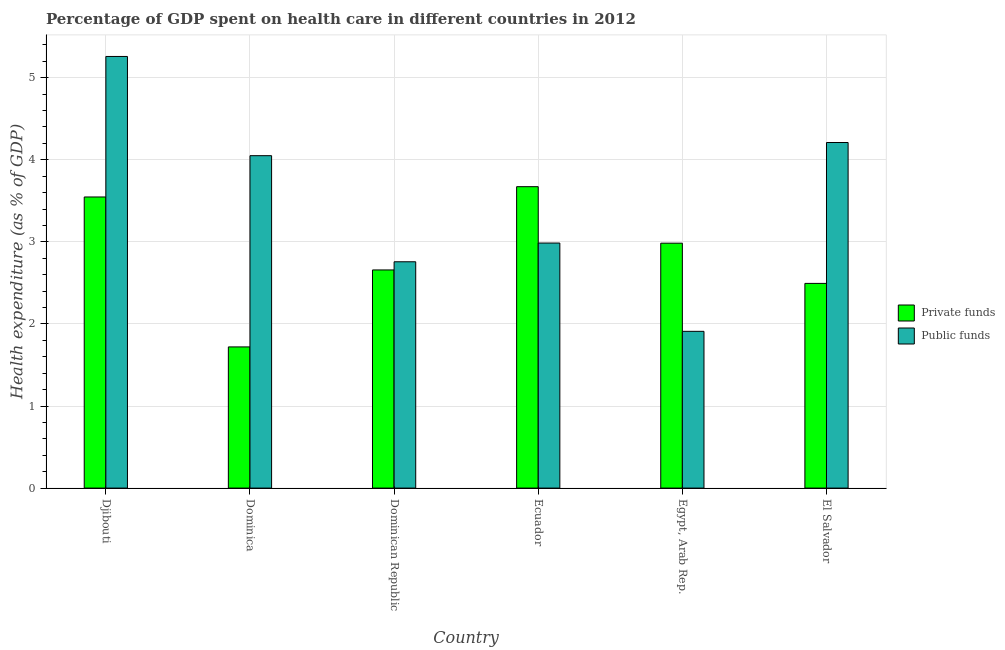How many different coloured bars are there?
Keep it short and to the point. 2. Are the number of bars on each tick of the X-axis equal?
Your response must be concise. Yes. What is the label of the 5th group of bars from the left?
Provide a short and direct response. Egypt, Arab Rep. What is the amount of public funds spent in healthcare in El Salvador?
Provide a succinct answer. 4.21. Across all countries, what is the maximum amount of public funds spent in healthcare?
Your answer should be compact. 5.26. Across all countries, what is the minimum amount of public funds spent in healthcare?
Give a very brief answer. 1.91. In which country was the amount of private funds spent in healthcare maximum?
Offer a very short reply. Ecuador. In which country was the amount of public funds spent in healthcare minimum?
Your answer should be compact. Egypt, Arab Rep. What is the total amount of private funds spent in healthcare in the graph?
Ensure brevity in your answer.  17.07. What is the difference between the amount of public funds spent in healthcare in Djibouti and that in Dominican Republic?
Your answer should be very brief. 2.5. What is the difference between the amount of public funds spent in healthcare in Ecuador and the amount of private funds spent in healthcare in El Salvador?
Give a very brief answer. 0.49. What is the average amount of public funds spent in healthcare per country?
Provide a succinct answer. 3.53. What is the difference between the amount of private funds spent in healthcare and amount of public funds spent in healthcare in Dominica?
Make the answer very short. -2.33. What is the ratio of the amount of private funds spent in healthcare in Djibouti to that in Dominica?
Provide a short and direct response. 2.06. Is the amount of public funds spent in healthcare in Djibouti less than that in El Salvador?
Provide a short and direct response. No. Is the difference between the amount of private funds spent in healthcare in Djibouti and Dominican Republic greater than the difference between the amount of public funds spent in healthcare in Djibouti and Dominican Republic?
Give a very brief answer. No. What is the difference between the highest and the second highest amount of public funds spent in healthcare?
Ensure brevity in your answer.  1.05. What is the difference between the highest and the lowest amount of private funds spent in healthcare?
Your answer should be compact. 1.95. Is the sum of the amount of private funds spent in healthcare in Djibouti and Ecuador greater than the maximum amount of public funds spent in healthcare across all countries?
Ensure brevity in your answer.  Yes. What does the 1st bar from the left in Dominica represents?
Your answer should be compact. Private funds. What does the 2nd bar from the right in Dominica represents?
Offer a terse response. Private funds. How many bars are there?
Your answer should be very brief. 12. Are the values on the major ticks of Y-axis written in scientific E-notation?
Give a very brief answer. No. How many legend labels are there?
Give a very brief answer. 2. What is the title of the graph?
Provide a succinct answer. Percentage of GDP spent on health care in different countries in 2012. What is the label or title of the X-axis?
Offer a terse response. Country. What is the label or title of the Y-axis?
Provide a short and direct response. Health expenditure (as % of GDP). What is the Health expenditure (as % of GDP) in Private funds in Djibouti?
Offer a terse response. 3.55. What is the Health expenditure (as % of GDP) of Public funds in Djibouti?
Keep it short and to the point. 5.26. What is the Health expenditure (as % of GDP) in Private funds in Dominica?
Ensure brevity in your answer.  1.72. What is the Health expenditure (as % of GDP) in Public funds in Dominica?
Keep it short and to the point. 4.05. What is the Health expenditure (as % of GDP) of Private funds in Dominican Republic?
Provide a succinct answer. 2.66. What is the Health expenditure (as % of GDP) in Public funds in Dominican Republic?
Offer a terse response. 2.76. What is the Health expenditure (as % of GDP) in Private funds in Ecuador?
Your answer should be compact. 3.67. What is the Health expenditure (as % of GDP) of Public funds in Ecuador?
Give a very brief answer. 2.99. What is the Health expenditure (as % of GDP) in Private funds in Egypt, Arab Rep.?
Provide a short and direct response. 2.98. What is the Health expenditure (as % of GDP) of Public funds in Egypt, Arab Rep.?
Provide a succinct answer. 1.91. What is the Health expenditure (as % of GDP) in Private funds in El Salvador?
Keep it short and to the point. 2.49. What is the Health expenditure (as % of GDP) of Public funds in El Salvador?
Give a very brief answer. 4.21. Across all countries, what is the maximum Health expenditure (as % of GDP) in Private funds?
Keep it short and to the point. 3.67. Across all countries, what is the maximum Health expenditure (as % of GDP) of Public funds?
Your response must be concise. 5.26. Across all countries, what is the minimum Health expenditure (as % of GDP) in Private funds?
Keep it short and to the point. 1.72. Across all countries, what is the minimum Health expenditure (as % of GDP) of Public funds?
Offer a very short reply. 1.91. What is the total Health expenditure (as % of GDP) of Private funds in the graph?
Your answer should be compact. 17.07. What is the total Health expenditure (as % of GDP) of Public funds in the graph?
Keep it short and to the point. 21.17. What is the difference between the Health expenditure (as % of GDP) of Private funds in Djibouti and that in Dominica?
Make the answer very short. 1.83. What is the difference between the Health expenditure (as % of GDP) of Public funds in Djibouti and that in Dominica?
Your answer should be very brief. 1.21. What is the difference between the Health expenditure (as % of GDP) in Private funds in Djibouti and that in Dominican Republic?
Your response must be concise. 0.89. What is the difference between the Health expenditure (as % of GDP) of Public funds in Djibouti and that in Dominican Republic?
Ensure brevity in your answer.  2.5. What is the difference between the Health expenditure (as % of GDP) in Private funds in Djibouti and that in Ecuador?
Make the answer very short. -0.13. What is the difference between the Health expenditure (as % of GDP) of Public funds in Djibouti and that in Ecuador?
Give a very brief answer. 2.27. What is the difference between the Health expenditure (as % of GDP) in Private funds in Djibouti and that in Egypt, Arab Rep.?
Give a very brief answer. 0.56. What is the difference between the Health expenditure (as % of GDP) in Public funds in Djibouti and that in Egypt, Arab Rep.?
Provide a succinct answer. 3.35. What is the difference between the Health expenditure (as % of GDP) in Private funds in Djibouti and that in El Salvador?
Keep it short and to the point. 1.05. What is the difference between the Health expenditure (as % of GDP) in Public funds in Djibouti and that in El Salvador?
Keep it short and to the point. 1.05. What is the difference between the Health expenditure (as % of GDP) in Private funds in Dominica and that in Dominican Republic?
Your response must be concise. -0.94. What is the difference between the Health expenditure (as % of GDP) in Public funds in Dominica and that in Dominican Republic?
Offer a very short reply. 1.29. What is the difference between the Health expenditure (as % of GDP) in Private funds in Dominica and that in Ecuador?
Ensure brevity in your answer.  -1.95. What is the difference between the Health expenditure (as % of GDP) in Public funds in Dominica and that in Ecuador?
Ensure brevity in your answer.  1.06. What is the difference between the Health expenditure (as % of GDP) of Private funds in Dominica and that in Egypt, Arab Rep.?
Your response must be concise. -1.26. What is the difference between the Health expenditure (as % of GDP) in Public funds in Dominica and that in Egypt, Arab Rep.?
Your answer should be compact. 2.14. What is the difference between the Health expenditure (as % of GDP) of Private funds in Dominica and that in El Salvador?
Provide a succinct answer. -0.77. What is the difference between the Health expenditure (as % of GDP) of Public funds in Dominica and that in El Salvador?
Offer a terse response. -0.16. What is the difference between the Health expenditure (as % of GDP) in Private funds in Dominican Republic and that in Ecuador?
Ensure brevity in your answer.  -1.01. What is the difference between the Health expenditure (as % of GDP) of Public funds in Dominican Republic and that in Ecuador?
Ensure brevity in your answer.  -0.23. What is the difference between the Health expenditure (as % of GDP) of Private funds in Dominican Republic and that in Egypt, Arab Rep.?
Your answer should be compact. -0.33. What is the difference between the Health expenditure (as % of GDP) in Public funds in Dominican Republic and that in Egypt, Arab Rep.?
Provide a succinct answer. 0.85. What is the difference between the Health expenditure (as % of GDP) of Private funds in Dominican Republic and that in El Salvador?
Ensure brevity in your answer.  0.16. What is the difference between the Health expenditure (as % of GDP) in Public funds in Dominican Republic and that in El Salvador?
Provide a succinct answer. -1.45. What is the difference between the Health expenditure (as % of GDP) in Private funds in Ecuador and that in Egypt, Arab Rep.?
Give a very brief answer. 0.69. What is the difference between the Health expenditure (as % of GDP) in Public funds in Ecuador and that in Egypt, Arab Rep.?
Offer a very short reply. 1.08. What is the difference between the Health expenditure (as % of GDP) in Private funds in Ecuador and that in El Salvador?
Provide a succinct answer. 1.18. What is the difference between the Health expenditure (as % of GDP) in Public funds in Ecuador and that in El Salvador?
Make the answer very short. -1.22. What is the difference between the Health expenditure (as % of GDP) of Private funds in Egypt, Arab Rep. and that in El Salvador?
Give a very brief answer. 0.49. What is the difference between the Health expenditure (as % of GDP) of Public funds in Egypt, Arab Rep. and that in El Salvador?
Provide a succinct answer. -2.3. What is the difference between the Health expenditure (as % of GDP) in Private funds in Djibouti and the Health expenditure (as % of GDP) in Public funds in Dominica?
Your answer should be compact. -0.5. What is the difference between the Health expenditure (as % of GDP) of Private funds in Djibouti and the Health expenditure (as % of GDP) of Public funds in Dominican Republic?
Your answer should be compact. 0.79. What is the difference between the Health expenditure (as % of GDP) in Private funds in Djibouti and the Health expenditure (as % of GDP) in Public funds in Ecuador?
Provide a short and direct response. 0.56. What is the difference between the Health expenditure (as % of GDP) in Private funds in Djibouti and the Health expenditure (as % of GDP) in Public funds in Egypt, Arab Rep.?
Ensure brevity in your answer.  1.64. What is the difference between the Health expenditure (as % of GDP) of Private funds in Djibouti and the Health expenditure (as % of GDP) of Public funds in El Salvador?
Provide a short and direct response. -0.66. What is the difference between the Health expenditure (as % of GDP) of Private funds in Dominica and the Health expenditure (as % of GDP) of Public funds in Dominican Republic?
Your answer should be compact. -1.04. What is the difference between the Health expenditure (as % of GDP) in Private funds in Dominica and the Health expenditure (as % of GDP) in Public funds in Ecuador?
Your answer should be very brief. -1.27. What is the difference between the Health expenditure (as % of GDP) of Private funds in Dominica and the Health expenditure (as % of GDP) of Public funds in Egypt, Arab Rep.?
Your answer should be very brief. -0.19. What is the difference between the Health expenditure (as % of GDP) in Private funds in Dominica and the Health expenditure (as % of GDP) in Public funds in El Salvador?
Your answer should be very brief. -2.49. What is the difference between the Health expenditure (as % of GDP) in Private funds in Dominican Republic and the Health expenditure (as % of GDP) in Public funds in Ecuador?
Ensure brevity in your answer.  -0.33. What is the difference between the Health expenditure (as % of GDP) in Private funds in Dominican Republic and the Health expenditure (as % of GDP) in Public funds in Egypt, Arab Rep.?
Your answer should be compact. 0.75. What is the difference between the Health expenditure (as % of GDP) of Private funds in Dominican Republic and the Health expenditure (as % of GDP) of Public funds in El Salvador?
Ensure brevity in your answer.  -1.55. What is the difference between the Health expenditure (as % of GDP) in Private funds in Ecuador and the Health expenditure (as % of GDP) in Public funds in Egypt, Arab Rep.?
Give a very brief answer. 1.76. What is the difference between the Health expenditure (as % of GDP) of Private funds in Ecuador and the Health expenditure (as % of GDP) of Public funds in El Salvador?
Your answer should be very brief. -0.54. What is the difference between the Health expenditure (as % of GDP) in Private funds in Egypt, Arab Rep. and the Health expenditure (as % of GDP) in Public funds in El Salvador?
Ensure brevity in your answer.  -1.23. What is the average Health expenditure (as % of GDP) of Private funds per country?
Keep it short and to the point. 2.85. What is the average Health expenditure (as % of GDP) in Public funds per country?
Offer a very short reply. 3.53. What is the difference between the Health expenditure (as % of GDP) in Private funds and Health expenditure (as % of GDP) in Public funds in Djibouti?
Your answer should be compact. -1.71. What is the difference between the Health expenditure (as % of GDP) of Private funds and Health expenditure (as % of GDP) of Public funds in Dominica?
Give a very brief answer. -2.33. What is the difference between the Health expenditure (as % of GDP) of Private funds and Health expenditure (as % of GDP) of Public funds in Dominican Republic?
Your response must be concise. -0.1. What is the difference between the Health expenditure (as % of GDP) in Private funds and Health expenditure (as % of GDP) in Public funds in Ecuador?
Ensure brevity in your answer.  0.69. What is the difference between the Health expenditure (as % of GDP) of Private funds and Health expenditure (as % of GDP) of Public funds in Egypt, Arab Rep.?
Offer a very short reply. 1.07. What is the difference between the Health expenditure (as % of GDP) in Private funds and Health expenditure (as % of GDP) in Public funds in El Salvador?
Give a very brief answer. -1.72. What is the ratio of the Health expenditure (as % of GDP) of Private funds in Djibouti to that in Dominica?
Make the answer very short. 2.06. What is the ratio of the Health expenditure (as % of GDP) in Public funds in Djibouti to that in Dominica?
Provide a succinct answer. 1.3. What is the ratio of the Health expenditure (as % of GDP) of Private funds in Djibouti to that in Dominican Republic?
Ensure brevity in your answer.  1.33. What is the ratio of the Health expenditure (as % of GDP) of Public funds in Djibouti to that in Dominican Republic?
Keep it short and to the point. 1.91. What is the ratio of the Health expenditure (as % of GDP) in Private funds in Djibouti to that in Ecuador?
Provide a succinct answer. 0.97. What is the ratio of the Health expenditure (as % of GDP) in Public funds in Djibouti to that in Ecuador?
Ensure brevity in your answer.  1.76. What is the ratio of the Health expenditure (as % of GDP) of Private funds in Djibouti to that in Egypt, Arab Rep.?
Your response must be concise. 1.19. What is the ratio of the Health expenditure (as % of GDP) in Public funds in Djibouti to that in Egypt, Arab Rep.?
Offer a terse response. 2.75. What is the ratio of the Health expenditure (as % of GDP) of Private funds in Djibouti to that in El Salvador?
Offer a terse response. 1.42. What is the ratio of the Health expenditure (as % of GDP) of Public funds in Djibouti to that in El Salvador?
Ensure brevity in your answer.  1.25. What is the ratio of the Health expenditure (as % of GDP) of Private funds in Dominica to that in Dominican Republic?
Offer a very short reply. 0.65. What is the ratio of the Health expenditure (as % of GDP) of Public funds in Dominica to that in Dominican Republic?
Provide a succinct answer. 1.47. What is the ratio of the Health expenditure (as % of GDP) in Private funds in Dominica to that in Ecuador?
Your answer should be compact. 0.47. What is the ratio of the Health expenditure (as % of GDP) in Public funds in Dominica to that in Ecuador?
Give a very brief answer. 1.36. What is the ratio of the Health expenditure (as % of GDP) of Private funds in Dominica to that in Egypt, Arab Rep.?
Ensure brevity in your answer.  0.58. What is the ratio of the Health expenditure (as % of GDP) in Public funds in Dominica to that in Egypt, Arab Rep.?
Your response must be concise. 2.12. What is the ratio of the Health expenditure (as % of GDP) of Private funds in Dominica to that in El Salvador?
Your answer should be compact. 0.69. What is the ratio of the Health expenditure (as % of GDP) in Public funds in Dominica to that in El Salvador?
Offer a very short reply. 0.96. What is the ratio of the Health expenditure (as % of GDP) of Private funds in Dominican Republic to that in Ecuador?
Provide a short and direct response. 0.72. What is the ratio of the Health expenditure (as % of GDP) of Public funds in Dominican Republic to that in Ecuador?
Provide a short and direct response. 0.92. What is the ratio of the Health expenditure (as % of GDP) of Private funds in Dominican Republic to that in Egypt, Arab Rep.?
Provide a short and direct response. 0.89. What is the ratio of the Health expenditure (as % of GDP) in Public funds in Dominican Republic to that in Egypt, Arab Rep.?
Offer a very short reply. 1.44. What is the ratio of the Health expenditure (as % of GDP) in Private funds in Dominican Republic to that in El Salvador?
Provide a succinct answer. 1.07. What is the ratio of the Health expenditure (as % of GDP) of Public funds in Dominican Republic to that in El Salvador?
Make the answer very short. 0.65. What is the ratio of the Health expenditure (as % of GDP) of Private funds in Ecuador to that in Egypt, Arab Rep.?
Ensure brevity in your answer.  1.23. What is the ratio of the Health expenditure (as % of GDP) of Public funds in Ecuador to that in Egypt, Arab Rep.?
Offer a very short reply. 1.56. What is the ratio of the Health expenditure (as % of GDP) in Private funds in Ecuador to that in El Salvador?
Provide a short and direct response. 1.47. What is the ratio of the Health expenditure (as % of GDP) in Public funds in Ecuador to that in El Salvador?
Make the answer very short. 0.71. What is the ratio of the Health expenditure (as % of GDP) of Private funds in Egypt, Arab Rep. to that in El Salvador?
Make the answer very short. 1.2. What is the ratio of the Health expenditure (as % of GDP) in Public funds in Egypt, Arab Rep. to that in El Salvador?
Your answer should be compact. 0.45. What is the difference between the highest and the second highest Health expenditure (as % of GDP) of Private funds?
Your answer should be compact. 0.13. What is the difference between the highest and the second highest Health expenditure (as % of GDP) in Public funds?
Offer a very short reply. 1.05. What is the difference between the highest and the lowest Health expenditure (as % of GDP) of Private funds?
Provide a succinct answer. 1.95. What is the difference between the highest and the lowest Health expenditure (as % of GDP) in Public funds?
Give a very brief answer. 3.35. 